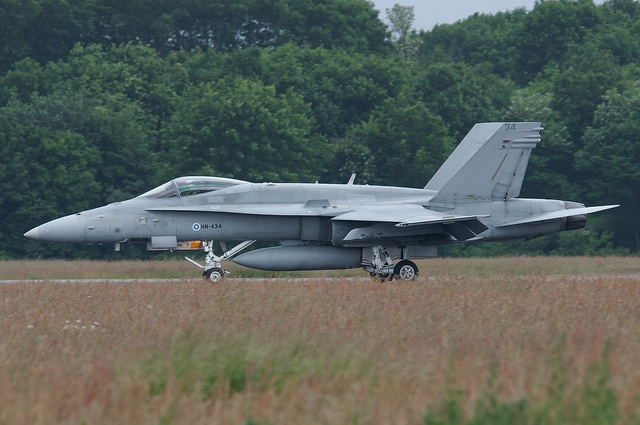Describe the objects in this image and their specific colors. I can see a airplane in purple, darkgray, gray, and black tones in this image. 